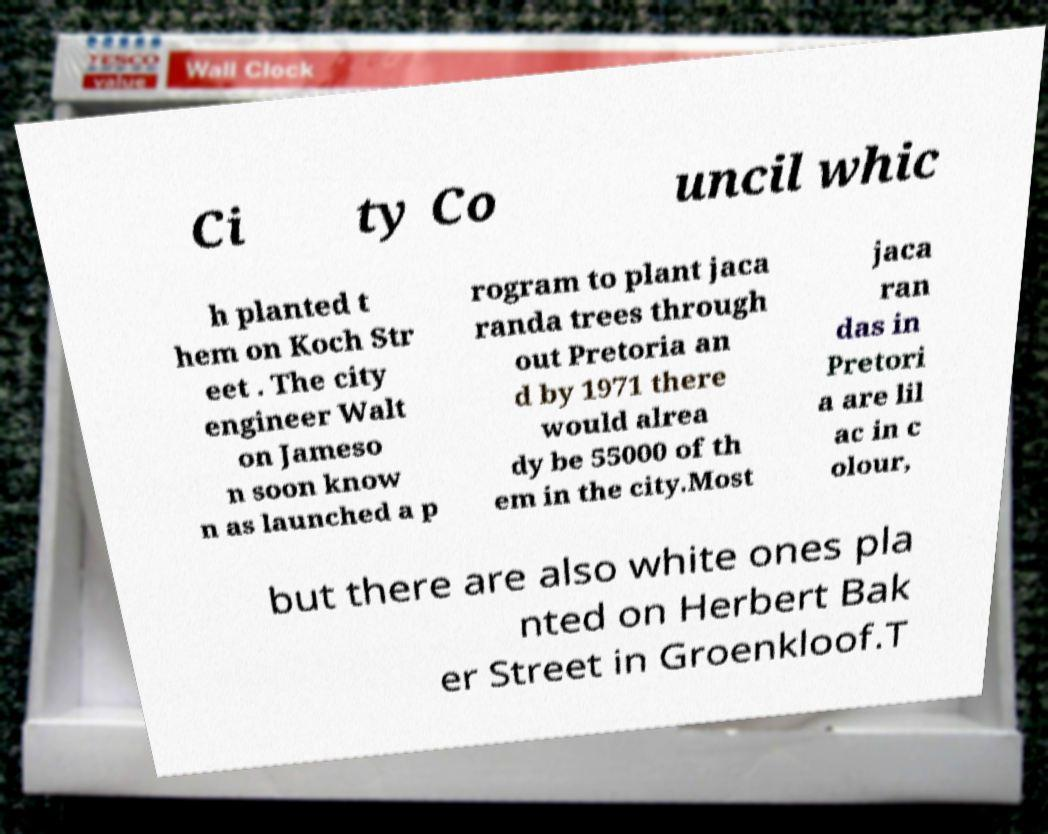Please read and relay the text visible in this image. What does it say? Ci ty Co uncil whic h planted t hem on Koch Str eet . The city engineer Walt on Jameso n soon know n as launched a p rogram to plant jaca randa trees through out Pretoria an d by 1971 there would alrea dy be 55000 of th em in the city.Most jaca ran das in Pretori a are lil ac in c olour, but there are also white ones pla nted on Herbert Bak er Street in Groenkloof.T 